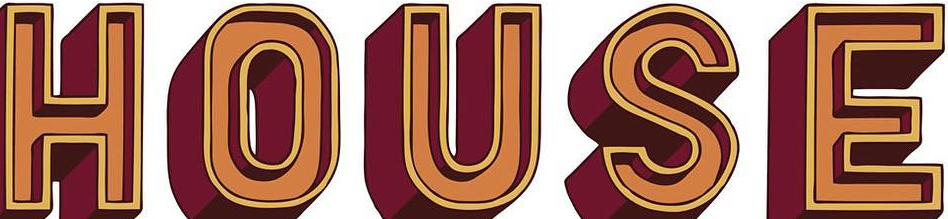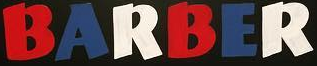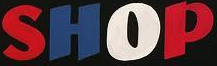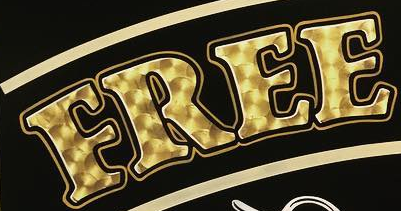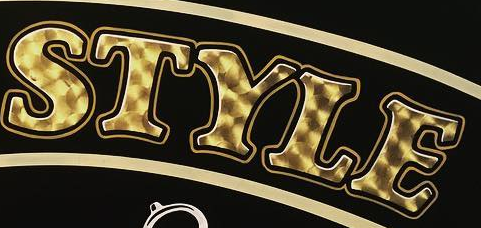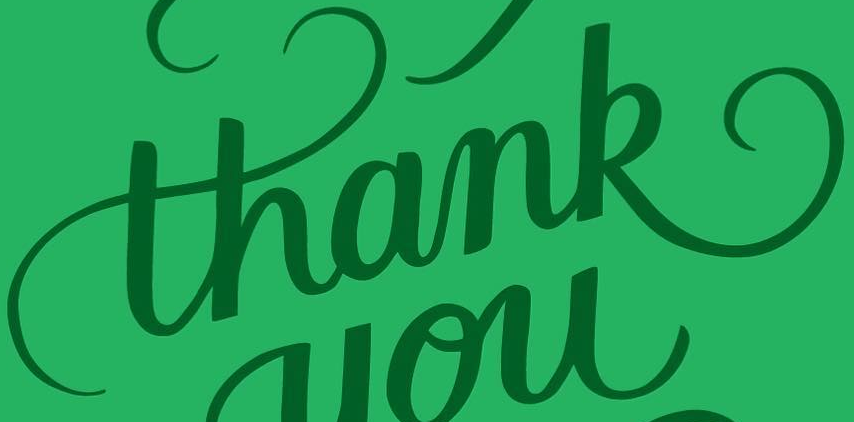Identify the words shown in these images in order, separated by a semicolon. HOUSE; BARBER; SHOP; FREE; STYLE; thank 